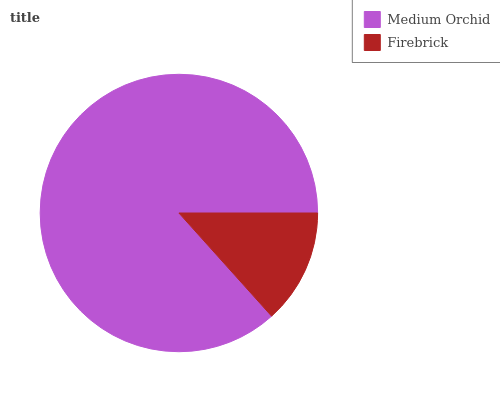Is Firebrick the minimum?
Answer yes or no. Yes. Is Medium Orchid the maximum?
Answer yes or no. Yes. Is Firebrick the maximum?
Answer yes or no. No. Is Medium Orchid greater than Firebrick?
Answer yes or no. Yes. Is Firebrick less than Medium Orchid?
Answer yes or no. Yes. Is Firebrick greater than Medium Orchid?
Answer yes or no. No. Is Medium Orchid less than Firebrick?
Answer yes or no. No. Is Medium Orchid the high median?
Answer yes or no. Yes. Is Firebrick the low median?
Answer yes or no. Yes. Is Firebrick the high median?
Answer yes or no. No. Is Medium Orchid the low median?
Answer yes or no. No. 